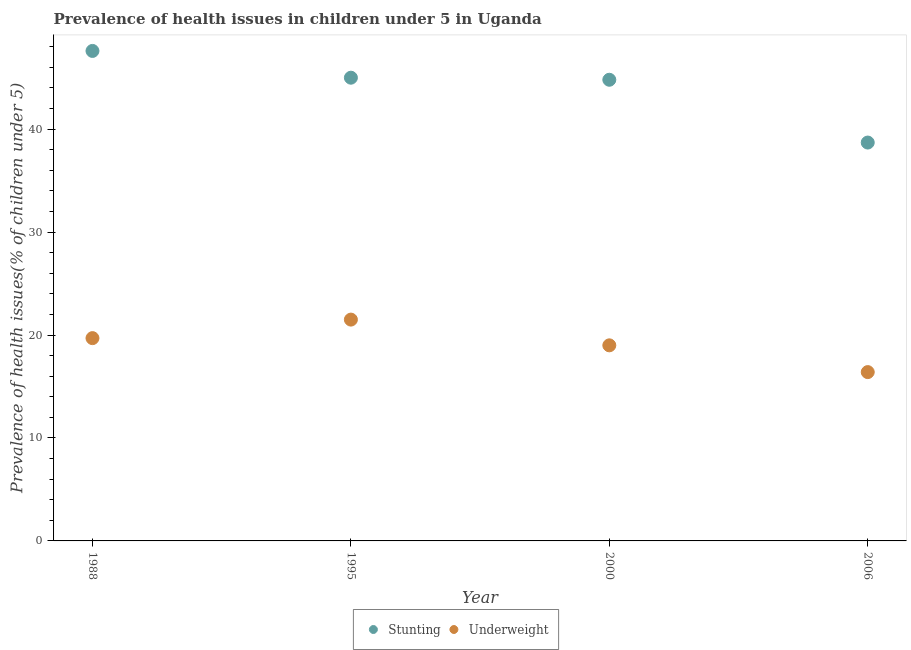How many different coloured dotlines are there?
Give a very brief answer. 2. Is the number of dotlines equal to the number of legend labels?
Your response must be concise. Yes. What is the percentage of underweight children in 1995?
Keep it short and to the point. 21.5. Across all years, what is the minimum percentage of underweight children?
Offer a very short reply. 16.4. In which year was the percentage of underweight children maximum?
Give a very brief answer. 1995. In which year was the percentage of underweight children minimum?
Your answer should be very brief. 2006. What is the total percentage of stunted children in the graph?
Make the answer very short. 176.1. What is the difference between the percentage of stunted children in 1988 and that in 2000?
Keep it short and to the point. 2.8. What is the average percentage of underweight children per year?
Make the answer very short. 19.15. In the year 1995, what is the difference between the percentage of stunted children and percentage of underweight children?
Your response must be concise. 23.5. What is the ratio of the percentage of stunted children in 1988 to that in 2006?
Your answer should be very brief. 1.23. Is the percentage of underweight children in 1988 less than that in 1995?
Provide a short and direct response. Yes. Is the difference between the percentage of underweight children in 1995 and 2006 greater than the difference between the percentage of stunted children in 1995 and 2006?
Provide a succinct answer. No. What is the difference between the highest and the second highest percentage of stunted children?
Provide a succinct answer. 2.6. What is the difference between the highest and the lowest percentage of stunted children?
Offer a very short reply. 8.9. In how many years, is the percentage of stunted children greater than the average percentage of stunted children taken over all years?
Keep it short and to the point. 3. Is the sum of the percentage of stunted children in 1988 and 2006 greater than the maximum percentage of underweight children across all years?
Your answer should be very brief. Yes. Does the percentage of stunted children monotonically increase over the years?
Offer a very short reply. No. Is the percentage of underweight children strictly greater than the percentage of stunted children over the years?
Provide a short and direct response. No. Is the percentage of stunted children strictly less than the percentage of underweight children over the years?
Your answer should be very brief. No. How many years are there in the graph?
Give a very brief answer. 4. What is the difference between two consecutive major ticks on the Y-axis?
Your answer should be very brief. 10. Are the values on the major ticks of Y-axis written in scientific E-notation?
Give a very brief answer. No. Does the graph contain any zero values?
Give a very brief answer. No. Where does the legend appear in the graph?
Your answer should be compact. Bottom center. How many legend labels are there?
Offer a very short reply. 2. What is the title of the graph?
Offer a very short reply. Prevalence of health issues in children under 5 in Uganda. What is the label or title of the Y-axis?
Keep it short and to the point. Prevalence of health issues(% of children under 5). What is the Prevalence of health issues(% of children under 5) in Stunting in 1988?
Give a very brief answer. 47.6. What is the Prevalence of health issues(% of children under 5) in Underweight in 1988?
Provide a short and direct response. 19.7. What is the Prevalence of health issues(% of children under 5) in Underweight in 1995?
Ensure brevity in your answer.  21.5. What is the Prevalence of health issues(% of children under 5) of Stunting in 2000?
Offer a terse response. 44.8. What is the Prevalence of health issues(% of children under 5) in Underweight in 2000?
Ensure brevity in your answer.  19. What is the Prevalence of health issues(% of children under 5) of Stunting in 2006?
Your answer should be compact. 38.7. What is the Prevalence of health issues(% of children under 5) in Underweight in 2006?
Ensure brevity in your answer.  16.4. Across all years, what is the maximum Prevalence of health issues(% of children under 5) in Stunting?
Offer a very short reply. 47.6. Across all years, what is the maximum Prevalence of health issues(% of children under 5) of Underweight?
Provide a succinct answer. 21.5. Across all years, what is the minimum Prevalence of health issues(% of children under 5) in Stunting?
Ensure brevity in your answer.  38.7. Across all years, what is the minimum Prevalence of health issues(% of children under 5) in Underweight?
Your answer should be compact. 16.4. What is the total Prevalence of health issues(% of children under 5) in Stunting in the graph?
Keep it short and to the point. 176.1. What is the total Prevalence of health issues(% of children under 5) of Underweight in the graph?
Your answer should be compact. 76.6. What is the difference between the Prevalence of health issues(% of children under 5) in Stunting in 1988 and that in 1995?
Keep it short and to the point. 2.6. What is the difference between the Prevalence of health issues(% of children under 5) in Underweight in 1988 and that in 1995?
Provide a short and direct response. -1.8. What is the difference between the Prevalence of health issues(% of children under 5) of Stunting in 1988 and that in 2000?
Ensure brevity in your answer.  2.8. What is the difference between the Prevalence of health issues(% of children under 5) of Underweight in 1995 and that in 2000?
Your answer should be very brief. 2.5. What is the difference between the Prevalence of health issues(% of children under 5) of Underweight in 1995 and that in 2006?
Your response must be concise. 5.1. What is the difference between the Prevalence of health issues(% of children under 5) of Underweight in 2000 and that in 2006?
Your response must be concise. 2.6. What is the difference between the Prevalence of health issues(% of children under 5) in Stunting in 1988 and the Prevalence of health issues(% of children under 5) in Underweight in 1995?
Your response must be concise. 26.1. What is the difference between the Prevalence of health issues(% of children under 5) of Stunting in 1988 and the Prevalence of health issues(% of children under 5) of Underweight in 2000?
Provide a succinct answer. 28.6. What is the difference between the Prevalence of health issues(% of children under 5) of Stunting in 1988 and the Prevalence of health issues(% of children under 5) of Underweight in 2006?
Keep it short and to the point. 31.2. What is the difference between the Prevalence of health issues(% of children under 5) in Stunting in 1995 and the Prevalence of health issues(% of children under 5) in Underweight in 2000?
Keep it short and to the point. 26. What is the difference between the Prevalence of health issues(% of children under 5) in Stunting in 1995 and the Prevalence of health issues(% of children under 5) in Underweight in 2006?
Give a very brief answer. 28.6. What is the difference between the Prevalence of health issues(% of children under 5) of Stunting in 2000 and the Prevalence of health issues(% of children under 5) of Underweight in 2006?
Your answer should be very brief. 28.4. What is the average Prevalence of health issues(% of children under 5) in Stunting per year?
Provide a short and direct response. 44.02. What is the average Prevalence of health issues(% of children under 5) of Underweight per year?
Your answer should be compact. 19.15. In the year 1988, what is the difference between the Prevalence of health issues(% of children under 5) in Stunting and Prevalence of health issues(% of children under 5) in Underweight?
Make the answer very short. 27.9. In the year 1995, what is the difference between the Prevalence of health issues(% of children under 5) in Stunting and Prevalence of health issues(% of children under 5) in Underweight?
Offer a very short reply. 23.5. In the year 2000, what is the difference between the Prevalence of health issues(% of children under 5) of Stunting and Prevalence of health issues(% of children under 5) of Underweight?
Your response must be concise. 25.8. In the year 2006, what is the difference between the Prevalence of health issues(% of children under 5) of Stunting and Prevalence of health issues(% of children under 5) of Underweight?
Provide a succinct answer. 22.3. What is the ratio of the Prevalence of health issues(% of children under 5) of Stunting in 1988 to that in 1995?
Ensure brevity in your answer.  1.06. What is the ratio of the Prevalence of health issues(% of children under 5) of Underweight in 1988 to that in 1995?
Provide a short and direct response. 0.92. What is the ratio of the Prevalence of health issues(% of children under 5) of Underweight in 1988 to that in 2000?
Give a very brief answer. 1.04. What is the ratio of the Prevalence of health issues(% of children under 5) in Stunting in 1988 to that in 2006?
Provide a succinct answer. 1.23. What is the ratio of the Prevalence of health issues(% of children under 5) in Underweight in 1988 to that in 2006?
Offer a terse response. 1.2. What is the ratio of the Prevalence of health issues(% of children under 5) in Stunting in 1995 to that in 2000?
Offer a terse response. 1. What is the ratio of the Prevalence of health issues(% of children under 5) in Underweight in 1995 to that in 2000?
Offer a very short reply. 1.13. What is the ratio of the Prevalence of health issues(% of children under 5) in Stunting in 1995 to that in 2006?
Keep it short and to the point. 1.16. What is the ratio of the Prevalence of health issues(% of children under 5) of Underweight in 1995 to that in 2006?
Your answer should be compact. 1.31. What is the ratio of the Prevalence of health issues(% of children under 5) in Stunting in 2000 to that in 2006?
Ensure brevity in your answer.  1.16. What is the ratio of the Prevalence of health issues(% of children under 5) in Underweight in 2000 to that in 2006?
Provide a short and direct response. 1.16. What is the difference between the highest and the second highest Prevalence of health issues(% of children under 5) of Stunting?
Ensure brevity in your answer.  2.6. What is the difference between the highest and the lowest Prevalence of health issues(% of children under 5) of Underweight?
Provide a short and direct response. 5.1. 